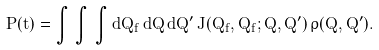<formula> <loc_0><loc_0><loc_500><loc_500>P ( t ) = \int \, \int \, \int d Q _ { f } \, d Q \, d Q ^ { \prime } \, J ( Q _ { f } , Q _ { f } ; Q , Q ^ { \prime } ) \, \rho ( Q , Q ^ { \prime } ) .</formula> 